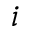<formula> <loc_0><loc_0><loc_500><loc_500>i</formula> 